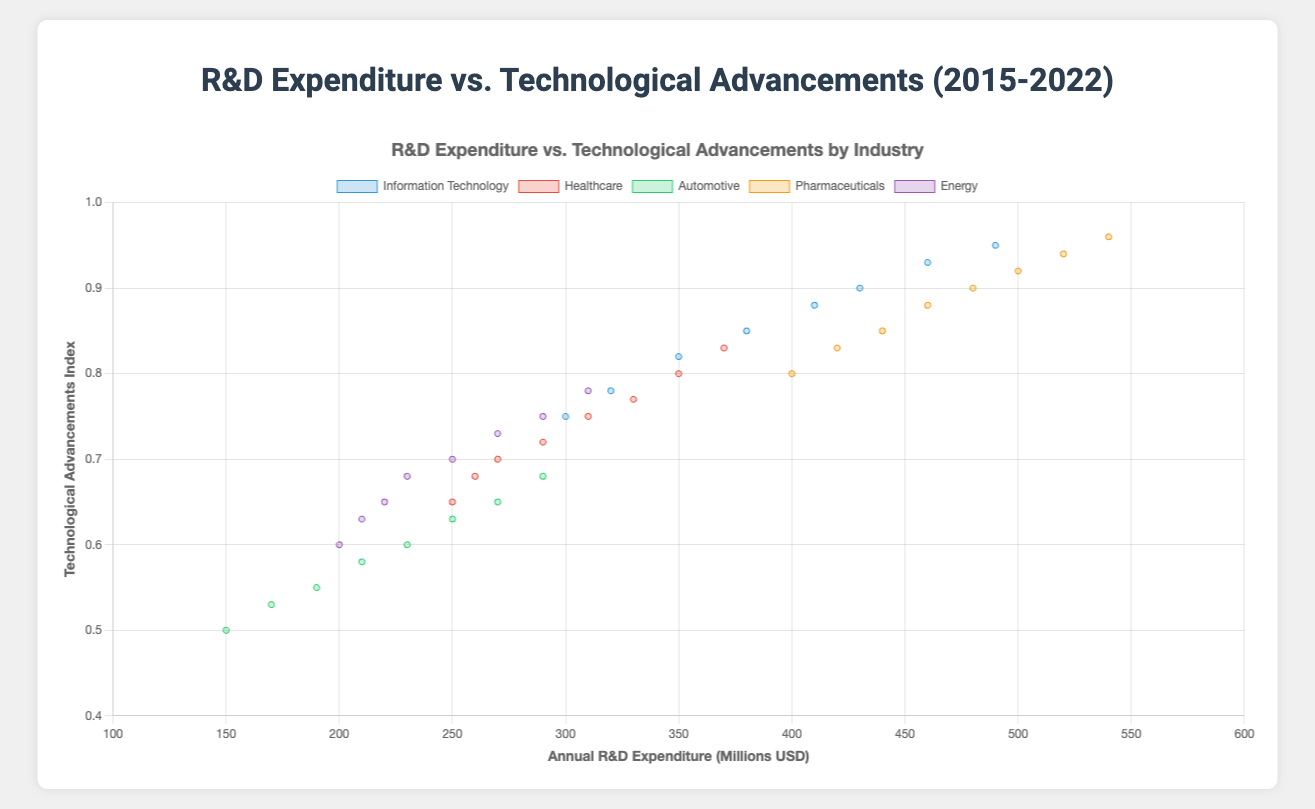What industry shows the highest technological advancements index in 2022? To find the industry with the highest technological advancements index in 2022, look at the y-values for each industry in the year 2022 and identify the maximum index.
Answer: Pharmaceuticals How does the R&D expenditure in the Information Technology industry compare to the Pharmaceuticals industry in 2020? Compare the x-values (expenditure) for both Information Technology and Pharmaceuticals in the year 2020.
Answer: Information Technology: $430M, Pharmaceuticals: $500M Which industry had the greatest increase in R&D expenditure from 2015 to 2022? Calculate the difference in R&D expenditure between 2015 and 2022 for each industry, and find the industry with the maximum increase.
Answer: Pharmaceuticals Is there an industry with an annual R&D expenditure below $200M in 2022? Check the x-values for each industry in the year 2022 to see if any expenditure is below $200M.
Answer: No What is the average technological advancements index for the Energy industry from 2015 to 2022? Sum the technological advancements indices for the Energy industry from 2015 to 2022 and divide by the number of years (8). (0.60 + 0.63 + 0.65 + 0.68 + 0.70 + 0.73 + 0.75 + 0.78) / 8 = 5.52 / 8 = 0.69
Answer: 0.69 Which industry shows the steepest increase in technological advancements index from 2015 to 2022? Determine the increase in technological advancements index for each industry from 2015 to 2022 and identify the one with the highest increase.
Answer: Pharmaceuticals Does the Healthcare industry show a consistent increase in R&D expenditure and technological advancements index from 2015 to 2022? Verify if both the R&D expenditure and technological advancements index for the Healthcare industry consistently increase from 2015 to 2022 without any decrease.
Answer: Yes In 2019, which industry had a higher technological advancements index: Automotive or Energy? Compare the y-values (tech advancements index) for Automotive and Energy industries in the year 2019.
Answer: Energy: 0.70, Automotive: 0.60 What is the correlation between annual R&D expenditure and technological advancements index in the Pharmaceuticals industry from 2015 to 2022? Based on the plot of the Pharmaceuticals industry, observe if there is a positive, negative, or no correlation between x (expenditure) and y (tech advancements index).
Answer: Positive correlation Compare the technological advancements between Information Technology and Energy industries in 2018. Look at the y-values for both Information Technology and Energy in the year 2018 to compare their technological advancements indexes.
Answer: Information Technology: 0.85, Energy: 0.68 